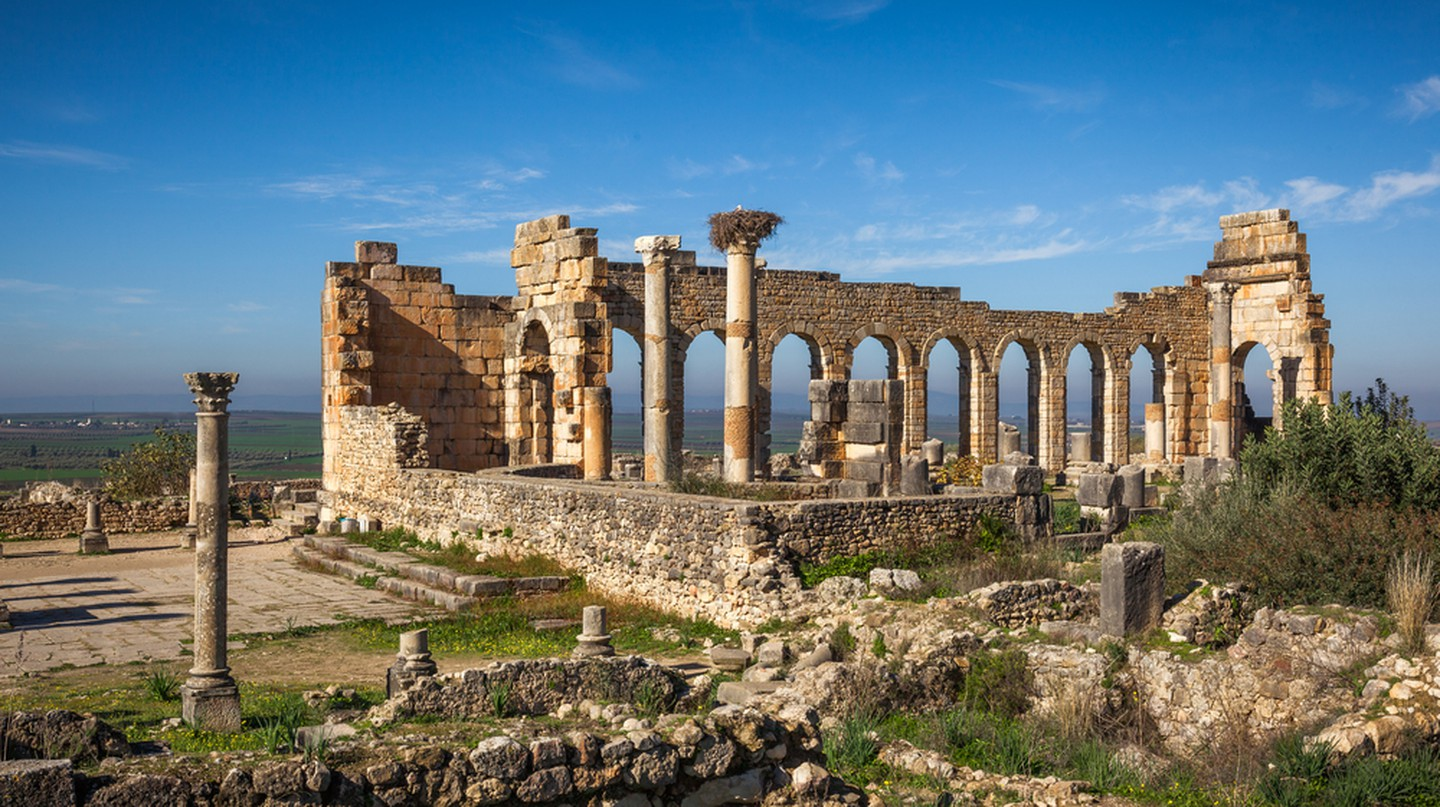Describe the following image. The image showcases the striking Roman ruins of Volubilis located in Morocco. These ruins are renowned for their well-preserved arches, columns, and stone walls, offering a window into the architectural sophistication of ancient Roman engineering. Positioned against a vast, clear sky and lush greenery, the ruins serve as a stark contrast, highlighting their historical significance amidst the natural beauty of the landscape. Volubilis, a UNESCO World Heritage site, was once a thriving administrative center of Roman Africa and provides invaluable insights into the cultural exchange and architectural prowess during the Roman Empire's expansion into North Africa. 